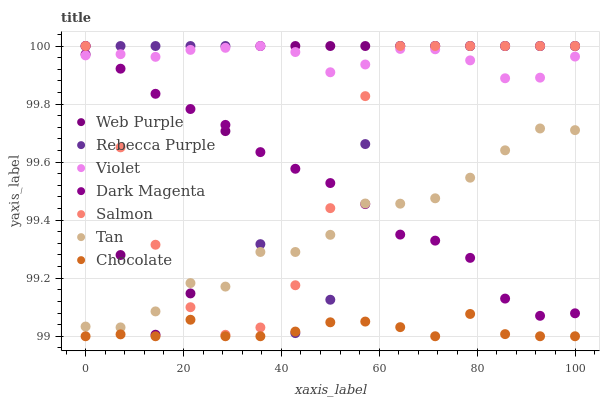Does Chocolate have the minimum area under the curve?
Answer yes or no. Yes. Does Violet have the maximum area under the curve?
Answer yes or no. Yes. Does Salmon have the minimum area under the curve?
Answer yes or no. No. Does Salmon have the maximum area under the curve?
Answer yes or no. No. Is Violet the smoothest?
Answer yes or no. Yes. Is Rebecca Purple the roughest?
Answer yes or no. Yes. Is Salmon the smoothest?
Answer yes or no. No. Is Salmon the roughest?
Answer yes or no. No. Does Chocolate have the lowest value?
Answer yes or no. Yes. Does Salmon have the lowest value?
Answer yes or no. No. Does Violet have the highest value?
Answer yes or no. Yes. Does Chocolate have the highest value?
Answer yes or no. No. Is Chocolate less than Salmon?
Answer yes or no. Yes. Is Violet greater than Chocolate?
Answer yes or no. Yes. Does Violet intersect Dark Magenta?
Answer yes or no. Yes. Is Violet less than Dark Magenta?
Answer yes or no. No. Is Violet greater than Dark Magenta?
Answer yes or no. No. Does Chocolate intersect Salmon?
Answer yes or no. No. 